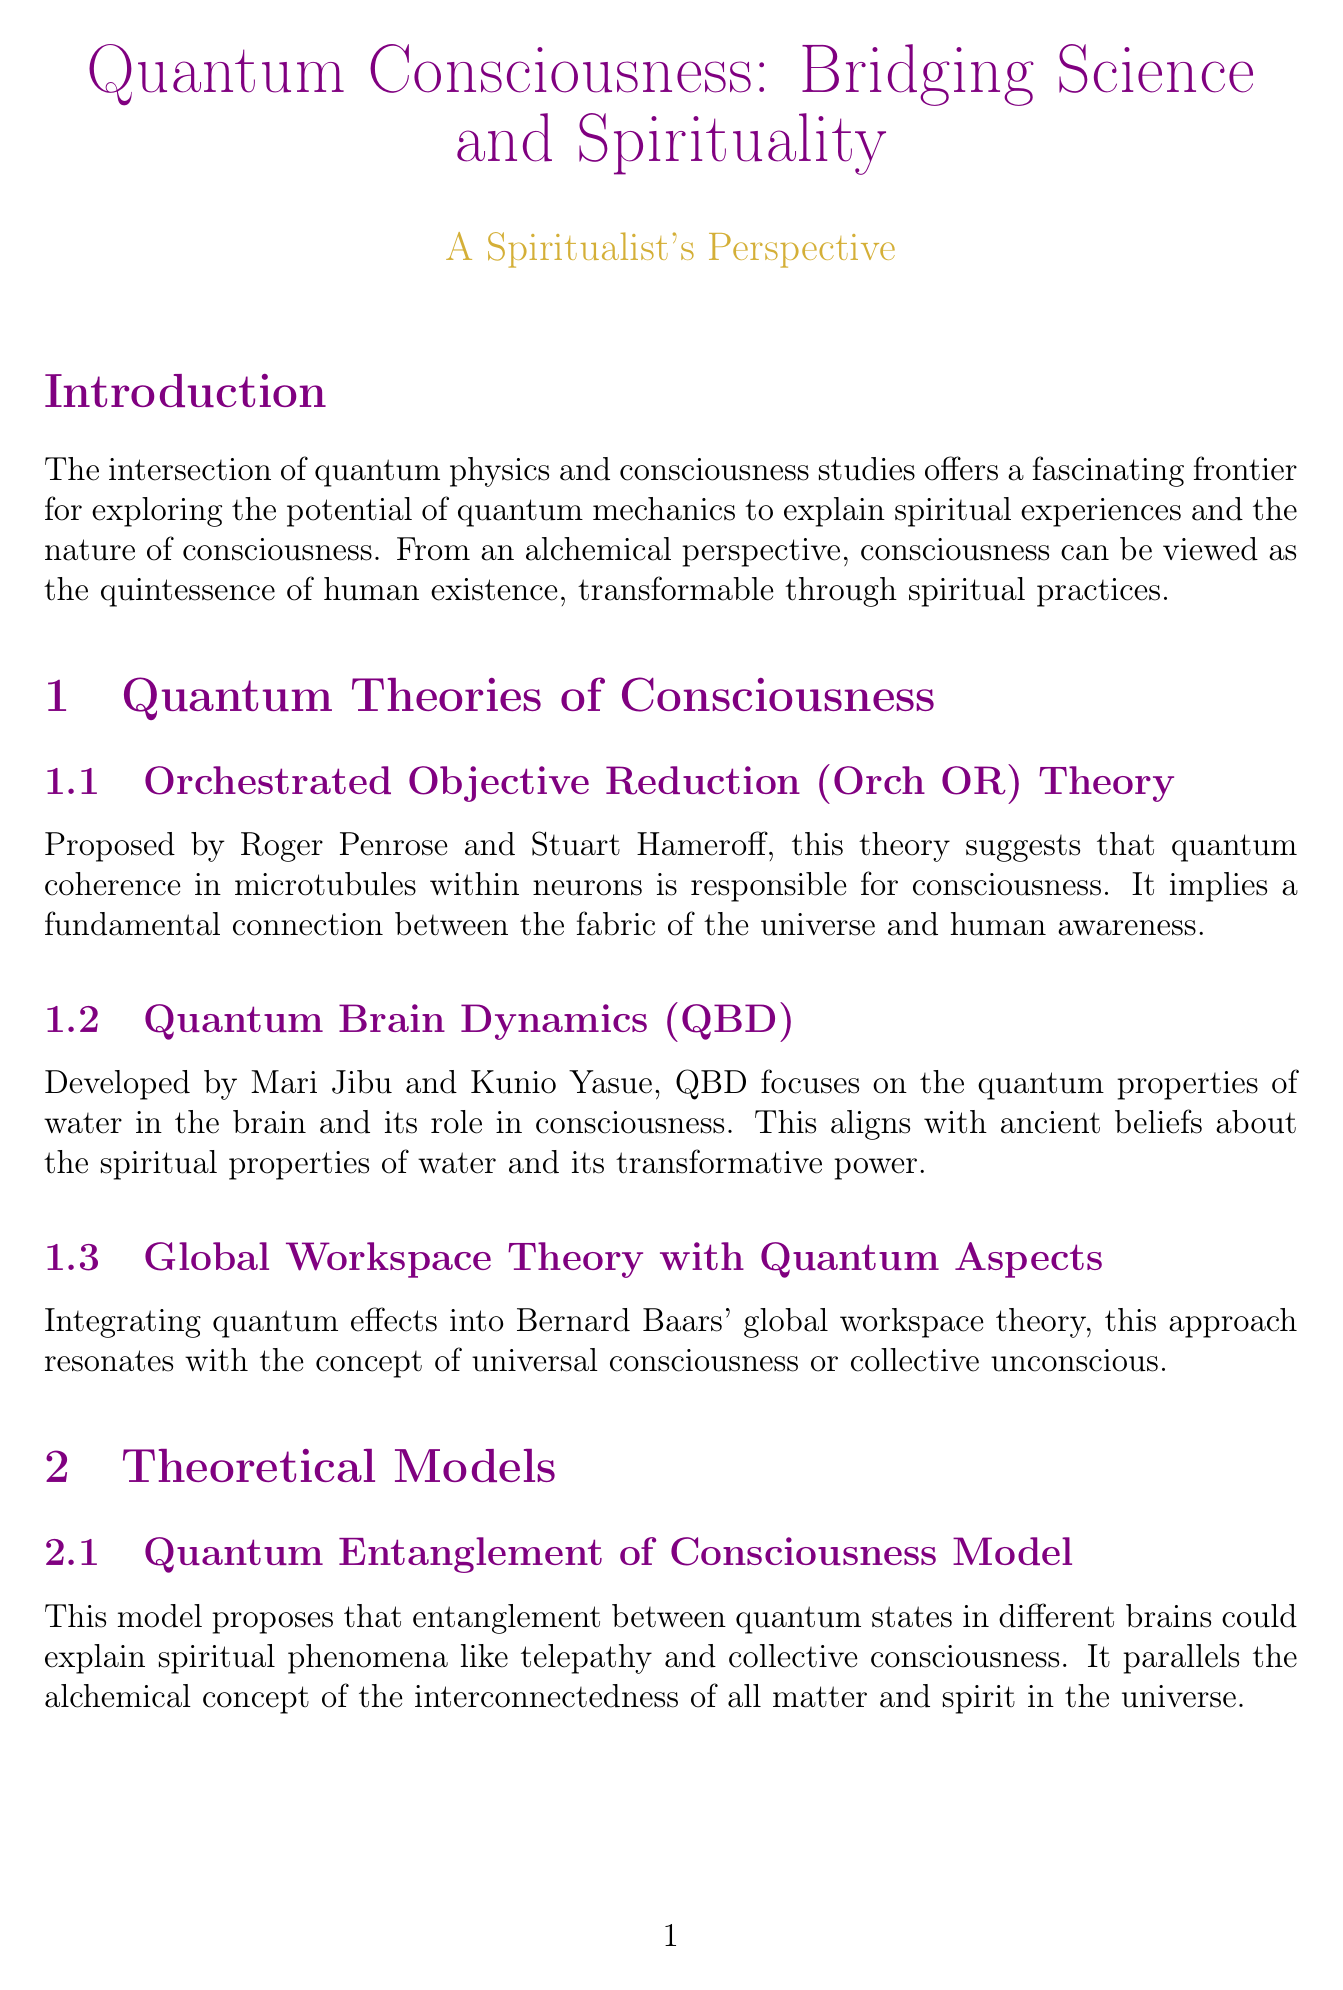What is the title of the report? The title of the report is stated at the beginning as "Quantum Consciousness: Bridging Science and Spirituality."
Answer: Quantum Consciousness: Bridging Science and Spirituality Who proposed the Orch OR theory? The Orch OR theory is proposed by Roger Penrose and Stuart Hameroff, as mentioned in the document.
Answer: Roger Penrose and Stuart Hameroff What does the Quantum Collapse and Free Will Model suggest? This model suggests that conscious choice causes wave function collapse, linking quantum indeterminacy to free will.
Answer: Conscious choice causes wave function collapse Which study indicated a potential field of collective consciousness? The study conducted by Roger Nelson, known as the Global Consciousness Project, indicated this possibility.
Answer: Global Consciousness Project What is a spiritual interpretation of the findings from the PEAR study? The spiritual interpretation of the PEAR study's findings suggests a subtle influence of mind over matter.
Answer: A subtle influence of mind over matter What phenomenon might quantum coherence in microtubules explain? Quantum coherence in microtubules could explain Near-Death Experiences (NDEs).
Answer: Near-Death Experiences (NDEs) 